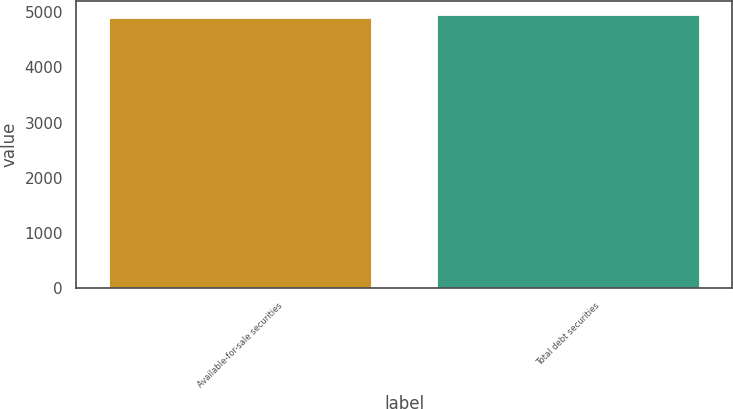<chart> <loc_0><loc_0><loc_500><loc_500><bar_chart><fcel>Available-for-sale securities<fcel>Total debt securities<nl><fcel>4901<fcel>4946<nl></chart> 